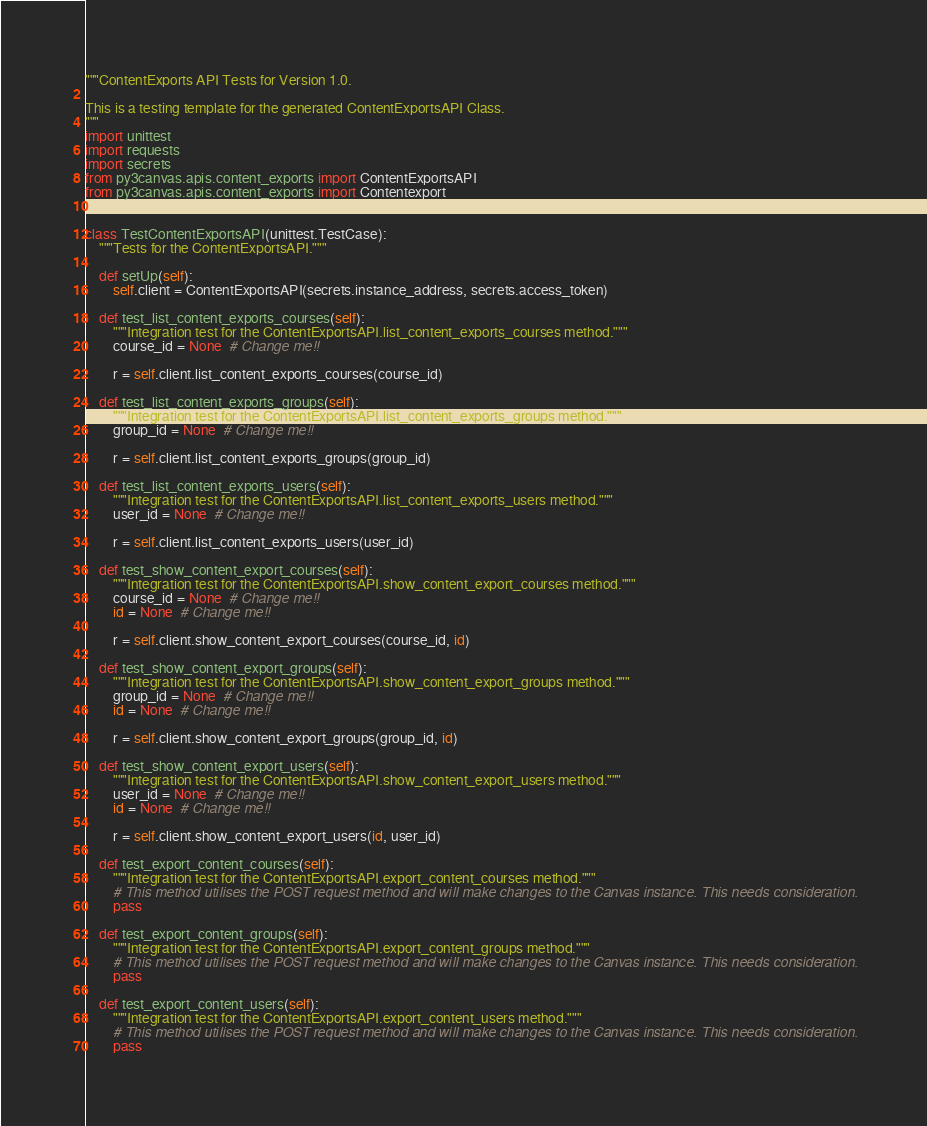<code> <loc_0><loc_0><loc_500><loc_500><_Python_>"""ContentExports API Tests for Version 1.0.

This is a testing template for the generated ContentExportsAPI Class.
"""
import unittest
import requests
import secrets
from py3canvas.apis.content_exports import ContentExportsAPI
from py3canvas.apis.content_exports import Contentexport


class TestContentExportsAPI(unittest.TestCase):
    """Tests for the ContentExportsAPI."""

    def setUp(self):
        self.client = ContentExportsAPI(secrets.instance_address, secrets.access_token)

    def test_list_content_exports_courses(self):
        """Integration test for the ContentExportsAPI.list_content_exports_courses method."""
        course_id = None  # Change me!!

        r = self.client.list_content_exports_courses(course_id)

    def test_list_content_exports_groups(self):
        """Integration test for the ContentExportsAPI.list_content_exports_groups method."""
        group_id = None  # Change me!!

        r = self.client.list_content_exports_groups(group_id)

    def test_list_content_exports_users(self):
        """Integration test for the ContentExportsAPI.list_content_exports_users method."""
        user_id = None  # Change me!!

        r = self.client.list_content_exports_users(user_id)

    def test_show_content_export_courses(self):
        """Integration test for the ContentExportsAPI.show_content_export_courses method."""
        course_id = None  # Change me!!
        id = None  # Change me!!

        r = self.client.show_content_export_courses(course_id, id)

    def test_show_content_export_groups(self):
        """Integration test for the ContentExportsAPI.show_content_export_groups method."""
        group_id = None  # Change me!!
        id = None  # Change me!!

        r = self.client.show_content_export_groups(group_id, id)

    def test_show_content_export_users(self):
        """Integration test for the ContentExportsAPI.show_content_export_users method."""
        user_id = None  # Change me!!
        id = None  # Change me!!

        r = self.client.show_content_export_users(id, user_id)

    def test_export_content_courses(self):
        """Integration test for the ContentExportsAPI.export_content_courses method."""
        # This method utilises the POST request method and will make changes to the Canvas instance. This needs consideration.
        pass

    def test_export_content_groups(self):
        """Integration test for the ContentExportsAPI.export_content_groups method."""
        # This method utilises the POST request method and will make changes to the Canvas instance. This needs consideration.
        pass

    def test_export_content_users(self):
        """Integration test for the ContentExportsAPI.export_content_users method."""
        # This method utilises the POST request method and will make changes to the Canvas instance. This needs consideration.
        pass
</code> 